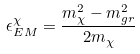Convert formula to latex. <formula><loc_0><loc_0><loc_500><loc_500>\epsilon ^ { \chi } _ { E M } = \frac { m ^ { 2 } _ { \chi } - m ^ { 2 } _ { g r } } { 2 m _ { \chi } }</formula> 